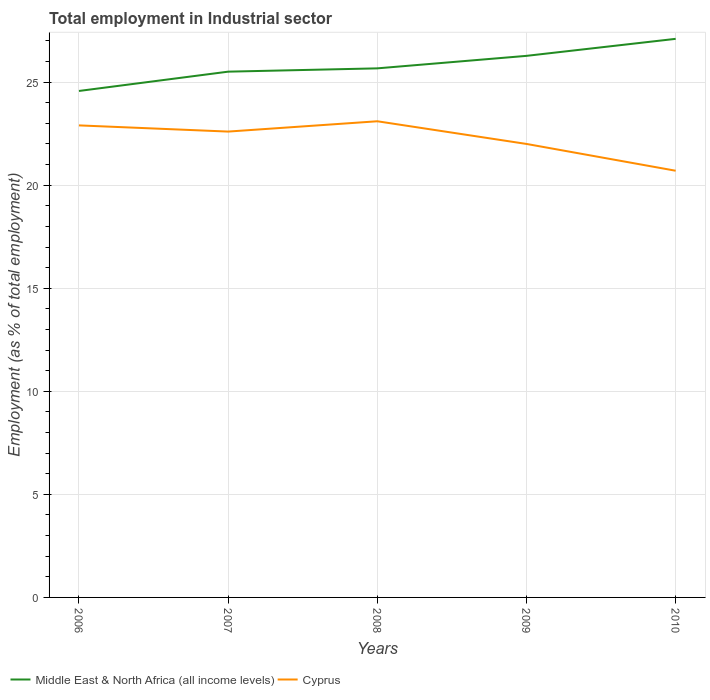Across all years, what is the maximum employment in industrial sector in Middle East & North Africa (all income levels)?
Offer a terse response. 24.57. In which year was the employment in industrial sector in Middle East & North Africa (all income levels) maximum?
Offer a terse response. 2006. What is the total employment in industrial sector in Middle East & North Africa (all income levels) in the graph?
Your response must be concise. -0.61. What is the difference between the highest and the second highest employment in industrial sector in Middle East & North Africa (all income levels)?
Keep it short and to the point. 2.53. What is the difference between the highest and the lowest employment in industrial sector in Cyprus?
Offer a very short reply. 3. Is the employment in industrial sector in Middle East & North Africa (all income levels) strictly greater than the employment in industrial sector in Cyprus over the years?
Offer a terse response. No. Are the values on the major ticks of Y-axis written in scientific E-notation?
Your answer should be compact. No. Does the graph contain grids?
Offer a terse response. Yes. Where does the legend appear in the graph?
Offer a very short reply. Bottom left. How are the legend labels stacked?
Your answer should be very brief. Horizontal. What is the title of the graph?
Your response must be concise. Total employment in Industrial sector. What is the label or title of the X-axis?
Ensure brevity in your answer.  Years. What is the label or title of the Y-axis?
Your answer should be very brief. Employment (as % of total employment). What is the Employment (as % of total employment) in Middle East & North Africa (all income levels) in 2006?
Your answer should be very brief. 24.57. What is the Employment (as % of total employment) in Cyprus in 2006?
Offer a very short reply. 22.9. What is the Employment (as % of total employment) of Middle East & North Africa (all income levels) in 2007?
Keep it short and to the point. 25.51. What is the Employment (as % of total employment) of Cyprus in 2007?
Offer a very short reply. 22.6. What is the Employment (as % of total employment) in Middle East & North Africa (all income levels) in 2008?
Make the answer very short. 25.67. What is the Employment (as % of total employment) in Cyprus in 2008?
Provide a short and direct response. 23.1. What is the Employment (as % of total employment) in Middle East & North Africa (all income levels) in 2009?
Your answer should be very brief. 26.27. What is the Employment (as % of total employment) in Middle East & North Africa (all income levels) in 2010?
Your answer should be compact. 27.1. What is the Employment (as % of total employment) in Cyprus in 2010?
Your response must be concise. 20.7. Across all years, what is the maximum Employment (as % of total employment) of Middle East & North Africa (all income levels)?
Give a very brief answer. 27.1. Across all years, what is the maximum Employment (as % of total employment) of Cyprus?
Your answer should be very brief. 23.1. Across all years, what is the minimum Employment (as % of total employment) of Middle East & North Africa (all income levels)?
Provide a succinct answer. 24.57. Across all years, what is the minimum Employment (as % of total employment) in Cyprus?
Your answer should be very brief. 20.7. What is the total Employment (as % of total employment) of Middle East & North Africa (all income levels) in the graph?
Offer a very short reply. 129.12. What is the total Employment (as % of total employment) of Cyprus in the graph?
Provide a succinct answer. 111.3. What is the difference between the Employment (as % of total employment) in Middle East & North Africa (all income levels) in 2006 and that in 2007?
Keep it short and to the point. -0.94. What is the difference between the Employment (as % of total employment) in Middle East & North Africa (all income levels) in 2006 and that in 2008?
Offer a very short reply. -1.1. What is the difference between the Employment (as % of total employment) in Middle East & North Africa (all income levels) in 2006 and that in 2009?
Provide a short and direct response. -1.7. What is the difference between the Employment (as % of total employment) of Middle East & North Africa (all income levels) in 2006 and that in 2010?
Your answer should be compact. -2.53. What is the difference between the Employment (as % of total employment) of Cyprus in 2006 and that in 2010?
Provide a succinct answer. 2.2. What is the difference between the Employment (as % of total employment) in Middle East & North Africa (all income levels) in 2007 and that in 2008?
Offer a terse response. -0.16. What is the difference between the Employment (as % of total employment) in Cyprus in 2007 and that in 2008?
Make the answer very short. -0.5. What is the difference between the Employment (as % of total employment) in Middle East & North Africa (all income levels) in 2007 and that in 2009?
Your response must be concise. -0.77. What is the difference between the Employment (as % of total employment) of Middle East & North Africa (all income levels) in 2007 and that in 2010?
Offer a terse response. -1.59. What is the difference between the Employment (as % of total employment) of Middle East & North Africa (all income levels) in 2008 and that in 2009?
Offer a very short reply. -0.61. What is the difference between the Employment (as % of total employment) in Cyprus in 2008 and that in 2009?
Give a very brief answer. 1.1. What is the difference between the Employment (as % of total employment) of Middle East & North Africa (all income levels) in 2008 and that in 2010?
Provide a succinct answer. -1.43. What is the difference between the Employment (as % of total employment) in Middle East & North Africa (all income levels) in 2009 and that in 2010?
Offer a terse response. -0.83. What is the difference between the Employment (as % of total employment) of Middle East & North Africa (all income levels) in 2006 and the Employment (as % of total employment) of Cyprus in 2007?
Your answer should be very brief. 1.97. What is the difference between the Employment (as % of total employment) in Middle East & North Africa (all income levels) in 2006 and the Employment (as % of total employment) in Cyprus in 2008?
Ensure brevity in your answer.  1.47. What is the difference between the Employment (as % of total employment) of Middle East & North Africa (all income levels) in 2006 and the Employment (as % of total employment) of Cyprus in 2009?
Provide a succinct answer. 2.57. What is the difference between the Employment (as % of total employment) of Middle East & North Africa (all income levels) in 2006 and the Employment (as % of total employment) of Cyprus in 2010?
Ensure brevity in your answer.  3.87. What is the difference between the Employment (as % of total employment) in Middle East & North Africa (all income levels) in 2007 and the Employment (as % of total employment) in Cyprus in 2008?
Provide a short and direct response. 2.41. What is the difference between the Employment (as % of total employment) of Middle East & North Africa (all income levels) in 2007 and the Employment (as % of total employment) of Cyprus in 2009?
Your answer should be compact. 3.51. What is the difference between the Employment (as % of total employment) in Middle East & North Africa (all income levels) in 2007 and the Employment (as % of total employment) in Cyprus in 2010?
Your answer should be very brief. 4.81. What is the difference between the Employment (as % of total employment) of Middle East & North Africa (all income levels) in 2008 and the Employment (as % of total employment) of Cyprus in 2009?
Make the answer very short. 3.67. What is the difference between the Employment (as % of total employment) in Middle East & North Africa (all income levels) in 2008 and the Employment (as % of total employment) in Cyprus in 2010?
Your answer should be compact. 4.97. What is the difference between the Employment (as % of total employment) in Middle East & North Africa (all income levels) in 2009 and the Employment (as % of total employment) in Cyprus in 2010?
Provide a short and direct response. 5.57. What is the average Employment (as % of total employment) of Middle East & North Africa (all income levels) per year?
Your answer should be very brief. 25.82. What is the average Employment (as % of total employment) in Cyprus per year?
Keep it short and to the point. 22.26. In the year 2006, what is the difference between the Employment (as % of total employment) of Middle East & North Africa (all income levels) and Employment (as % of total employment) of Cyprus?
Offer a very short reply. 1.67. In the year 2007, what is the difference between the Employment (as % of total employment) of Middle East & North Africa (all income levels) and Employment (as % of total employment) of Cyprus?
Offer a terse response. 2.91. In the year 2008, what is the difference between the Employment (as % of total employment) of Middle East & North Africa (all income levels) and Employment (as % of total employment) of Cyprus?
Make the answer very short. 2.57. In the year 2009, what is the difference between the Employment (as % of total employment) of Middle East & North Africa (all income levels) and Employment (as % of total employment) of Cyprus?
Your answer should be very brief. 4.27. In the year 2010, what is the difference between the Employment (as % of total employment) of Middle East & North Africa (all income levels) and Employment (as % of total employment) of Cyprus?
Keep it short and to the point. 6.4. What is the ratio of the Employment (as % of total employment) of Middle East & North Africa (all income levels) in 2006 to that in 2007?
Your response must be concise. 0.96. What is the ratio of the Employment (as % of total employment) in Cyprus in 2006 to that in 2007?
Offer a very short reply. 1.01. What is the ratio of the Employment (as % of total employment) in Middle East & North Africa (all income levels) in 2006 to that in 2008?
Your response must be concise. 0.96. What is the ratio of the Employment (as % of total employment) of Cyprus in 2006 to that in 2008?
Keep it short and to the point. 0.99. What is the ratio of the Employment (as % of total employment) in Middle East & North Africa (all income levels) in 2006 to that in 2009?
Provide a short and direct response. 0.94. What is the ratio of the Employment (as % of total employment) in Cyprus in 2006 to that in 2009?
Provide a short and direct response. 1.04. What is the ratio of the Employment (as % of total employment) of Middle East & North Africa (all income levels) in 2006 to that in 2010?
Make the answer very short. 0.91. What is the ratio of the Employment (as % of total employment) of Cyprus in 2006 to that in 2010?
Your answer should be very brief. 1.11. What is the ratio of the Employment (as % of total employment) of Cyprus in 2007 to that in 2008?
Make the answer very short. 0.98. What is the ratio of the Employment (as % of total employment) in Middle East & North Africa (all income levels) in 2007 to that in 2009?
Provide a short and direct response. 0.97. What is the ratio of the Employment (as % of total employment) of Cyprus in 2007 to that in 2009?
Make the answer very short. 1.03. What is the ratio of the Employment (as % of total employment) of Cyprus in 2007 to that in 2010?
Make the answer very short. 1.09. What is the ratio of the Employment (as % of total employment) of Middle East & North Africa (all income levels) in 2008 to that in 2009?
Offer a very short reply. 0.98. What is the ratio of the Employment (as % of total employment) of Cyprus in 2008 to that in 2009?
Offer a very short reply. 1.05. What is the ratio of the Employment (as % of total employment) in Middle East & North Africa (all income levels) in 2008 to that in 2010?
Provide a succinct answer. 0.95. What is the ratio of the Employment (as % of total employment) of Cyprus in 2008 to that in 2010?
Give a very brief answer. 1.12. What is the ratio of the Employment (as % of total employment) of Middle East & North Africa (all income levels) in 2009 to that in 2010?
Offer a very short reply. 0.97. What is the ratio of the Employment (as % of total employment) of Cyprus in 2009 to that in 2010?
Your answer should be compact. 1.06. What is the difference between the highest and the second highest Employment (as % of total employment) in Middle East & North Africa (all income levels)?
Provide a succinct answer. 0.83. What is the difference between the highest and the second highest Employment (as % of total employment) of Cyprus?
Offer a very short reply. 0.2. What is the difference between the highest and the lowest Employment (as % of total employment) of Middle East & North Africa (all income levels)?
Keep it short and to the point. 2.53. What is the difference between the highest and the lowest Employment (as % of total employment) of Cyprus?
Ensure brevity in your answer.  2.4. 